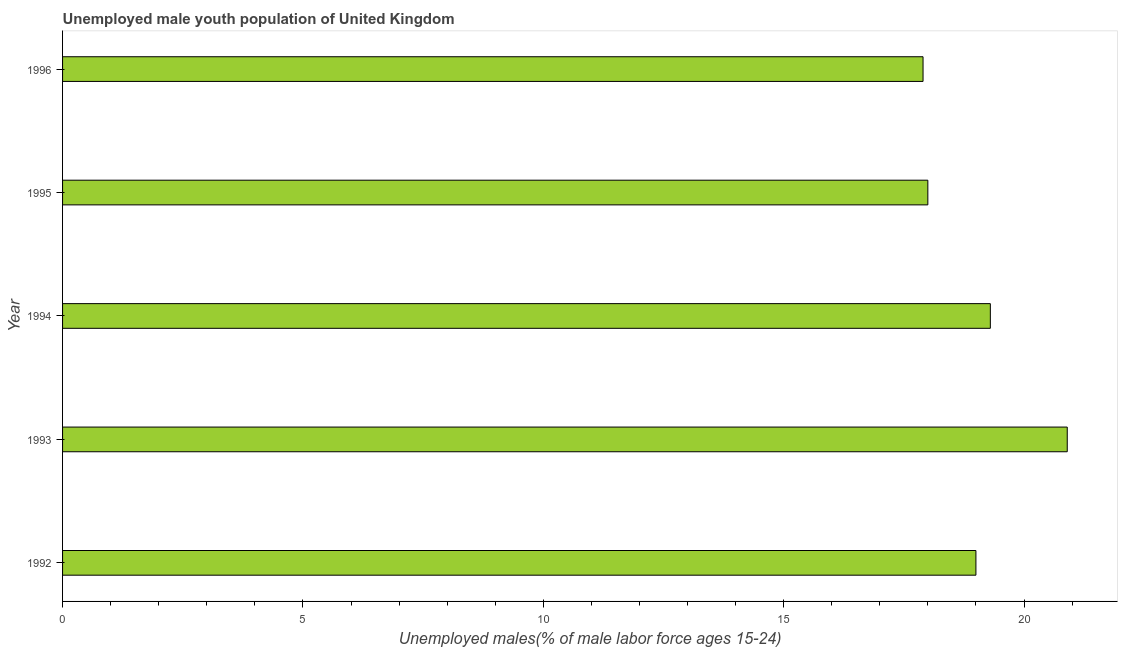What is the title of the graph?
Your answer should be very brief. Unemployed male youth population of United Kingdom. What is the label or title of the X-axis?
Your answer should be very brief. Unemployed males(% of male labor force ages 15-24). What is the label or title of the Y-axis?
Offer a terse response. Year. What is the unemployed male youth in 1996?
Your response must be concise. 17.9. Across all years, what is the maximum unemployed male youth?
Your response must be concise. 20.9. Across all years, what is the minimum unemployed male youth?
Offer a terse response. 17.9. What is the sum of the unemployed male youth?
Ensure brevity in your answer.  95.1. What is the average unemployed male youth per year?
Make the answer very short. 19.02. Do a majority of the years between 1995 and 1996 (inclusive) have unemployed male youth greater than 12 %?
Offer a terse response. Yes. What is the ratio of the unemployed male youth in 1994 to that in 1995?
Your answer should be compact. 1.07. Is the difference between the unemployed male youth in 1992 and 1993 greater than the difference between any two years?
Your response must be concise. No. What is the difference between the highest and the second highest unemployed male youth?
Your answer should be compact. 1.6. Is the sum of the unemployed male youth in 1995 and 1996 greater than the maximum unemployed male youth across all years?
Ensure brevity in your answer.  Yes. How many bars are there?
Provide a succinct answer. 5. Are all the bars in the graph horizontal?
Your answer should be compact. Yes. What is the Unemployed males(% of male labor force ages 15-24) of 1992?
Give a very brief answer. 19. What is the Unemployed males(% of male labor force ages 15-24) of 1993?
Keep it short and to the point. 20.9. What is the Unemployed males(% of male labor force ages 15-24) in 1994?
Give a very brief answer. 19.3. What is the Unemployed males(% of male labor force ages 15-24) of 1996?
Offer a very short reply. 17.9. What is the difference between the Unemployed males(% of male labor force ages 15-24) in 1992 and 1993?
Give a very brief answer. -1.9. What is the difference between the Unemployed males(% of male labor force ages 15-24) in 1994 and 1995?
Make the answer very short. 1.3. What is the ratio of the Unemployed males(% of male labor force ages 15-24) in 1992 to that in 1993?
Offer a very short reply. 0.91. What is the ratio of the Unemployed males(% of male labor force ages 15-24) in 1992 to that in 1995?
Offer a terse response. 1.06. What is the ratio of the Unemployed males(% of male labor force ages 15-24) in 1992 to that in 1996?
Make the answer very short. 1.06. What is the ratio of the Unemployed males(% of male labor force ages 15-24) in 1993 to that in 1994?
Offer a terse response. 1.08. What is the ratio of the Unemployed males(% of male labor force ages 15-24) in 1993 to that in 1995?
Provide a short and direct response. 1.16. What is the ratio of the Unemployed males(% of male labor force ages 15-24) in 1993 to that in 1996?
Your response must be concise. 1.17. What is the ratio of the Unemployed males(% of male labor force ages 15-24) in 1994 to that in 1995?
Your answer should be compact. 1.07. What is the ratio of the Unemployed males(% of male labor force ages 15-24) in 1994 to that in 1996?
Offer a terse response. 1.08. What is the ratio of the Unemployed males(% of male labor force ages 15-24) in 1995 to that in 1996?
Provide a short and direct response. 1.01. 